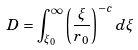<formula> <loc_0><loc_0><loc_500><loc_500>D = \int ^ { \infty } _ { \xi _ { 0 } } \left ( \frac { \xi } { r _ { 0 } } \right ) ^ { - c } d \xi</formula> 